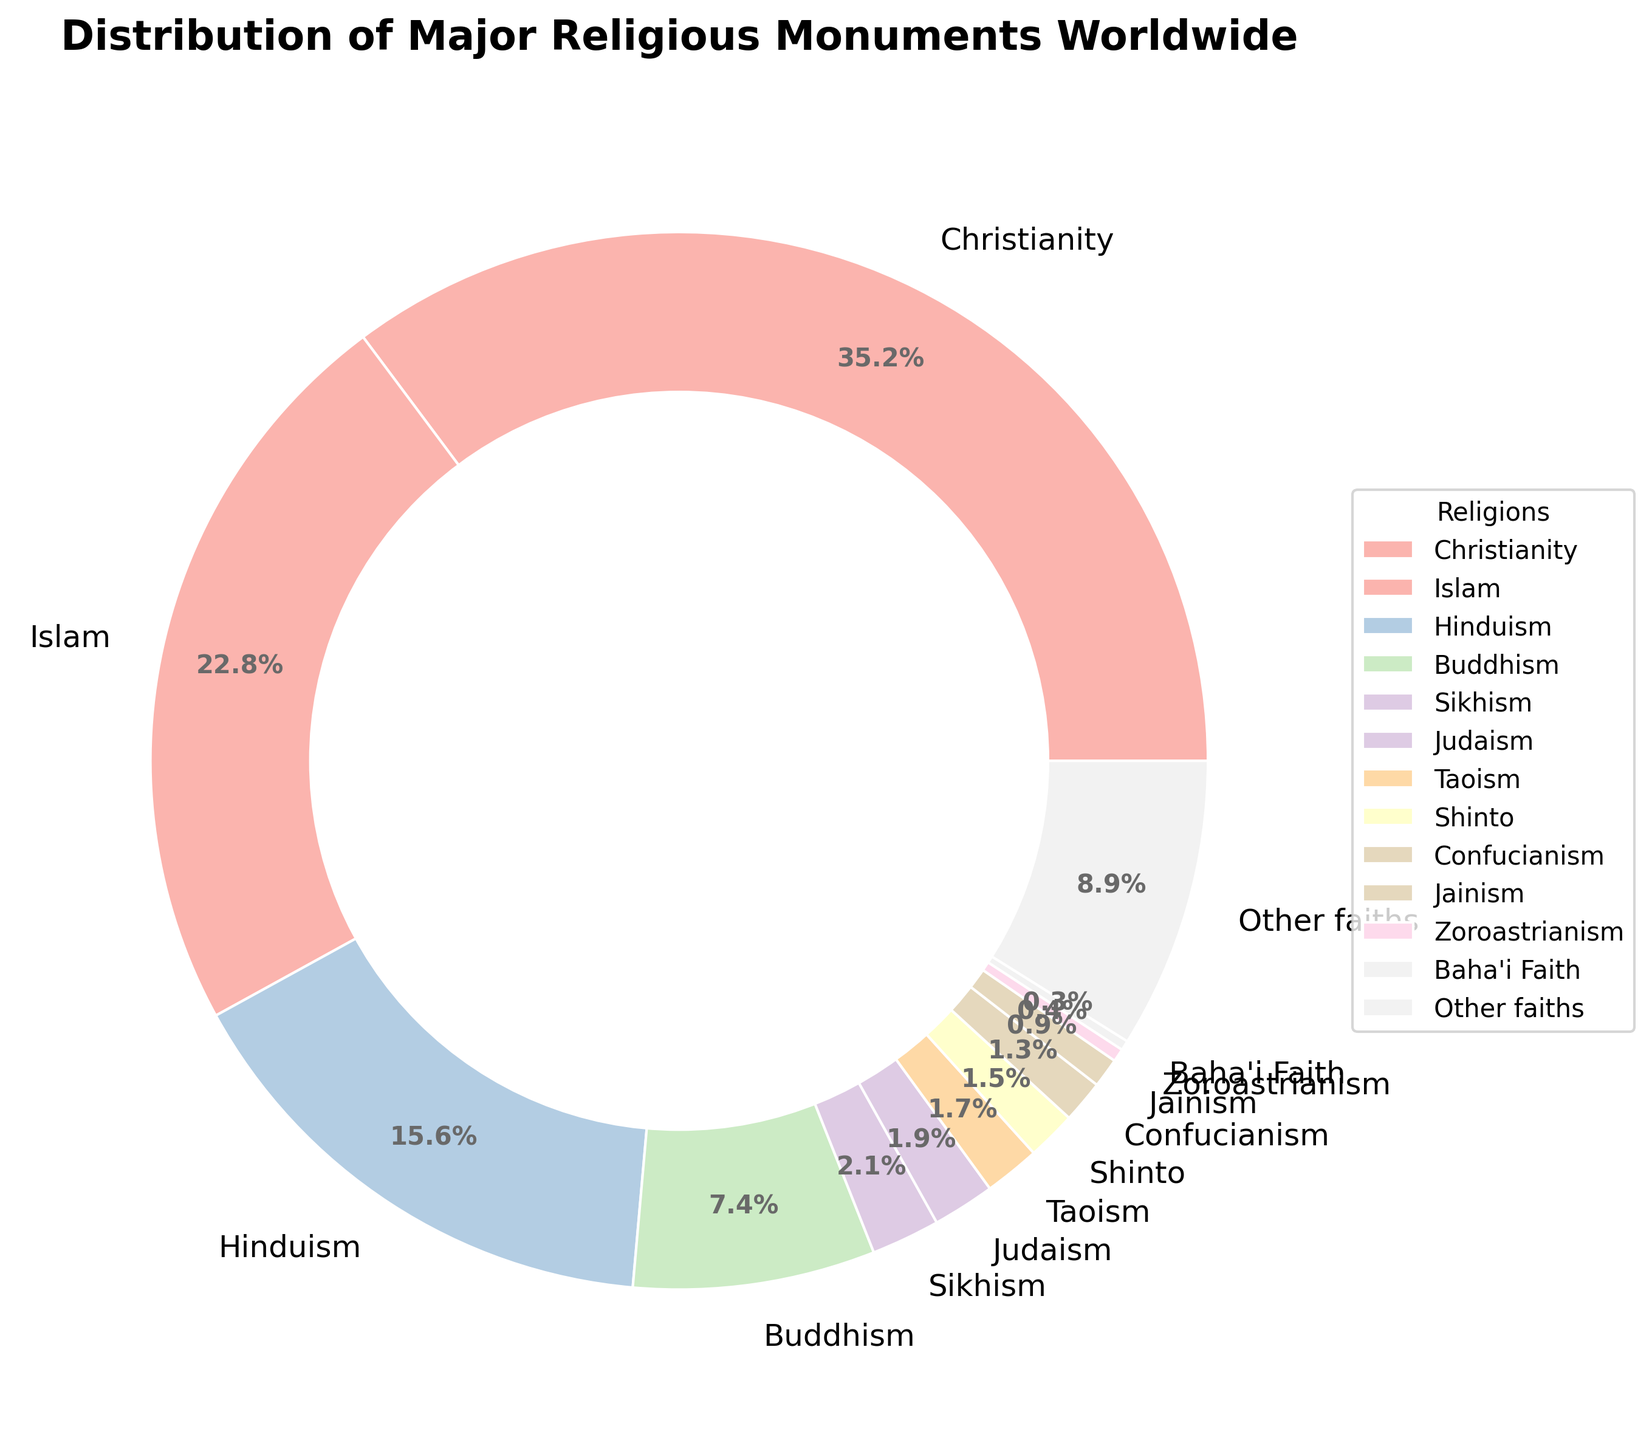Which religion has the highest distribution of religious monuments? Christianity has the highest percentage shown in the legend and chart section with the color representing it being noticeably larger than the others.
Answer: Christianity What is the combined percentage of religious monuments for Islam and Hinduism? Adding up the percentages provided in the chart: Islam (22.8%) + Hinduism (15.6%) = 22.8% + 15.6% = 38.4%
Answer: 38.4% How does the percentage of Buddhist monuments compare to that of Sikhism? Buddhism has 7.4% and Sikhism has 2.1%. We compare 7.4% to 2.1% to see that the percentage for Buddhist monuments is greater.
Answer: Buddhism has a higher percentage Is the distribution of religious monuments for Judaism greater than that for Shinto? Yes, Judaism is at 1.9% and Shinto is at 1.5%, comparing the two values we find 1.9% > 1.5%.
Answer: Yes What is the total percentage of monuments accounted for by Judaism, Sikhism, and Taoism? Sum the percentages: Judaism (1.9%) + Sikhism (2.1%) + Taoism (1.7%) = 1.9 + 2.1 + 1.7 = 5.7%
Answer: 5.7% Which religions together account for roughly 50% of all major religious monuments? By adding the percentages, we find that Christianity (35.2%) + Islam (22.8%) = 58%. Hence, Christianity and Islam together account for more than 50%. If we only consider Christianity + Hinduism = 35.2% + 15.6% = 50.8%, showing that round combinations involving Christianity and Islam or Christianity and Hinduism exceed 50%.
Answer: Christianity & Islam or Christianity & Hinduism How does the percentage of Hinduism compare to the sum of Zoroastrianism and Baha'i Faith? Hinduism is 15.6%, while the sum of Zoroastrianism (0.4%) and Baha'i Faith (0.3%) is 0.4% + 0.3% = 0.7%. Therefore, the Hinduism percentage is significantly higher.
Answer: Hinduism is greater What percentage of monuments belong to religions other than the top four (Christianity, Islam, Hinduism, Buddhism)? Combine the percentages of Christianity, Islam, Hinduism, and Buddhism: 35.2% + 22.8% + 15.6% + 7.4% = 81%. Then subtract this from 100%: 100% - 81% = 19%
Answer: 19% What is the difference between the percentage of the top religion and the second top religion? Observe that Christianity has 35.2% and Islam has 22.8%. Their difference is 35.2% - 22.8% = 12.4%
Answer: 12.4% How many religions have a percentage lower than 2%? The chart shows Judaism (1.9%), Taoism (1.7%), Shinto (1.5%), Confucianism (1.3%), Jainism (0.9%), Zoroastrianism (0.4%), and Baha'i Faith (0.3%)—count: 1, 2, 3, 4, 5, 6, 7
Answer: 7 